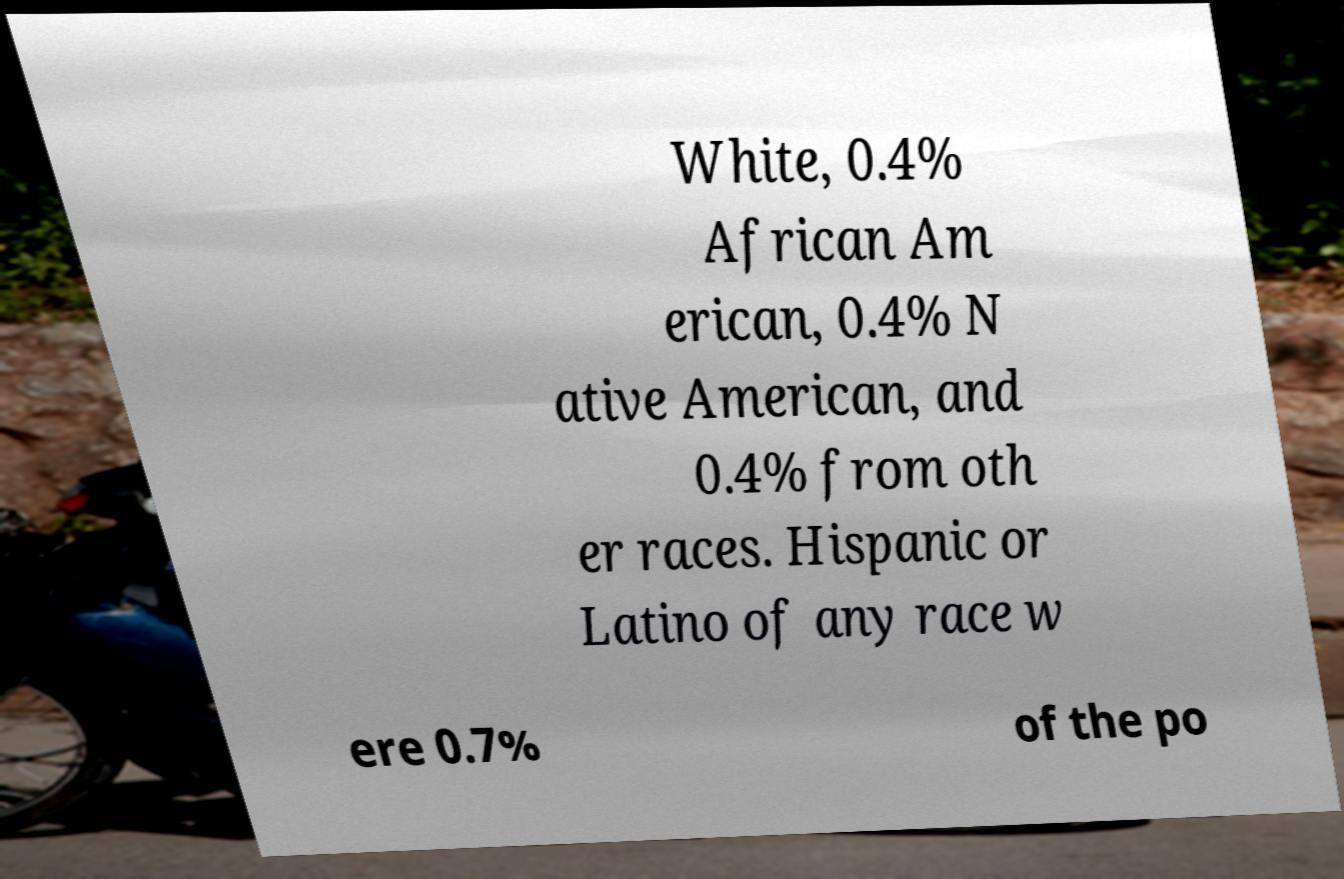Could you extract and type out the text from this image? White, 0.4% African Am erican, 0.4% N ative American, and 0.4% from oth er races. Hispanic or Latino of any race w ere 0.7% of the po 